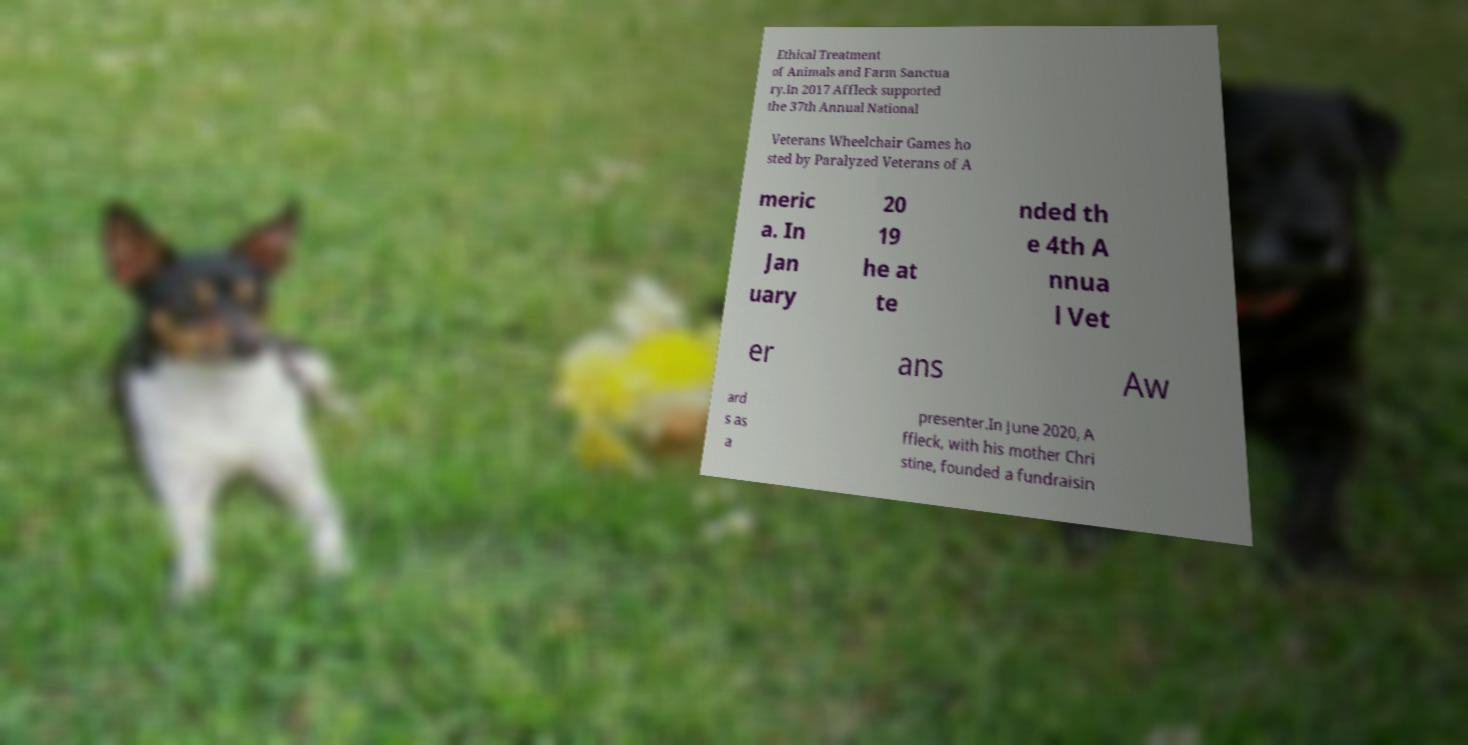Can you read and provide the text displayed in the image?This photo seems to have some interesting text. Can you extract and type it out for me? Ethical Treatment of Animals and Farm Sanctua ry.In 2017 Affleck supported the 37th Annual National Veterans Wheelchair Games ho sted by Paralyzed Veterans of A meric a. In Jan uary 20 19 he at te nded th e 4th A nnua l Vet er ans Aw ard s as a presenter.In June 2020, A ffleck, with his mother Chri stine, founded a fundraisin 